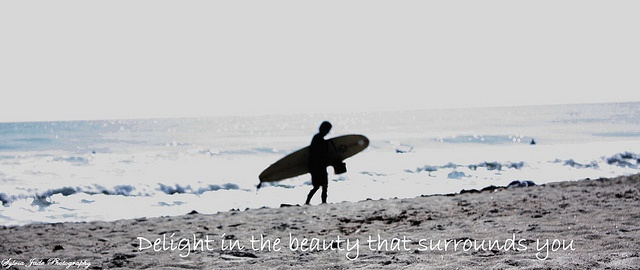Describe the objects in this image and their specific colors. I can see surfboard in lightgray, black, gray, and darkgray tones and people in lightgray, black, gray, and darkgray tones in this image. 